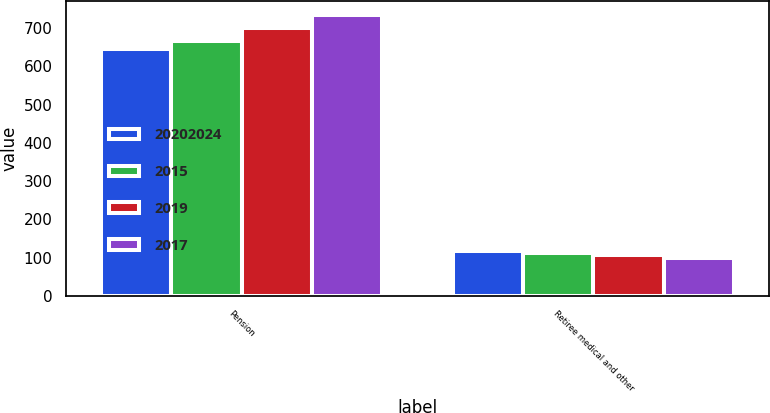Convert chart. <chart><loc_0><loc_0><loc_500><loc_500><stacked_bar_chart><ecel><fcel>Pension<fcel>Retiree medical and other<nl><fcel>2.0202e+07<fcel>645<fcel>117<nl><fcel>2015<fcel>667<fcel>111<nl><fcel>2019<fcel>699<fcel>106<nl><fcel>2017<fcel>735<fcel>100<nl></chart> 